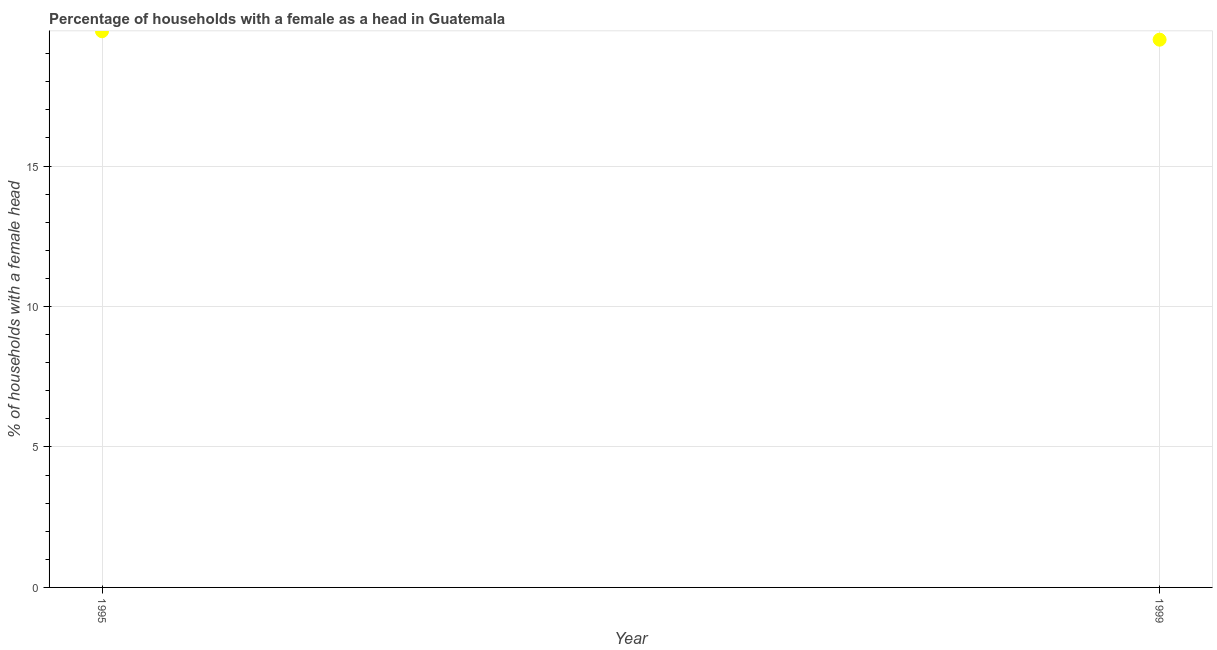What is the number of female supervised households in 1995?
Give a very brief answer. 19.8. Across all years, what is the maximum number of female supervised households?
Your answer should be very brief. 19.8. Across all years, what is the minimum number of female supervised households?
Provide a succinct answer. 19.5. What is the sum of the number of female supervised households?
Give a very brief answer. 39.3. What is the difference between the number of female supervised households in 1995 and 1999?
Offer a very short reply. 0.3. What is the average number of female supervised households per year?
Your answer should be compact. 19.65. What is the median number of female supervised households?
Offer a terse response. 19.65. In how many years, is the number of female supervised households greater than 12 %?
Keep it short and to the point. 2. Do a majority of the years between 1999 and 1995 (inclusive) have number of female supervised households greater than 3 %?
Your answer should be very brief. No. What is the ratio of the number of female supervised households in 1995 to that in 1999?
Give a very brief answer. 1.02. Is the number of female supervised households in 1995 less than that in 1999?
Provide a succinct answer. No. Does the graph contain grids?
Your answer should be very brief. Yes. What is the title of the graph?
Your answer should be compact. Percentage of households with a female as a head in Guatemala. What is the label or title of the Y-axis?
Offer a very short reply. % of households with a female head. What is the % of households with a female head in 1995?
Offer a very short reply. 19.8. 